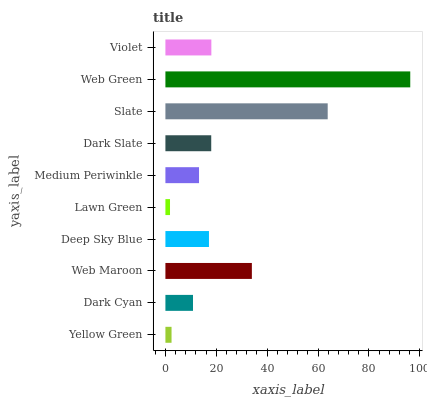Is Lawn Green the minimum?
Answer yes or no. Yes. Is Web Green the maximum?
Answer yes or no. Yes. Is Dark Cyan the minimum?
Answer yes or no. No. Is Dark Cyan the maximum?
Answer yes or no. No. Is Dark Cyan greater than Yellow Green?
Answer yes or no. Yes. Is Yellow Green less than Dark Cyan?
Answer yes or no. Yes. Is Yellow Green greater than Dark Cyan?
Answer yes or no. No. Is Dark Cyan less than Yellow Green?
Answer yes or no. No. Is Dark Slate the high median?
Answer yes or no. Yes. Is Deep Sky Blue the low median?
Answer yes or no. Yes. Is Web Green the high median?
Answer yes or no. No. Is Dark Slate the low median?
Answer yes or no. No. 